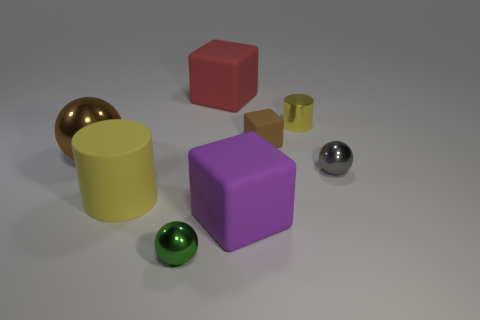Add 1 yellow blocks. How many objects exist? 9 Subtract all spheres. How many objects are left? 5 Subtract all small yellow cubes. Subtract all yellow metal objects. How many objects are left? 7 Add 5 small yellow cylinders. How many small yellow cylinders are left? 6 Add 6 brown matte things. How many brown matte things exist? 7 Subtract 0 purple cylinders. How many objects are left? 8 